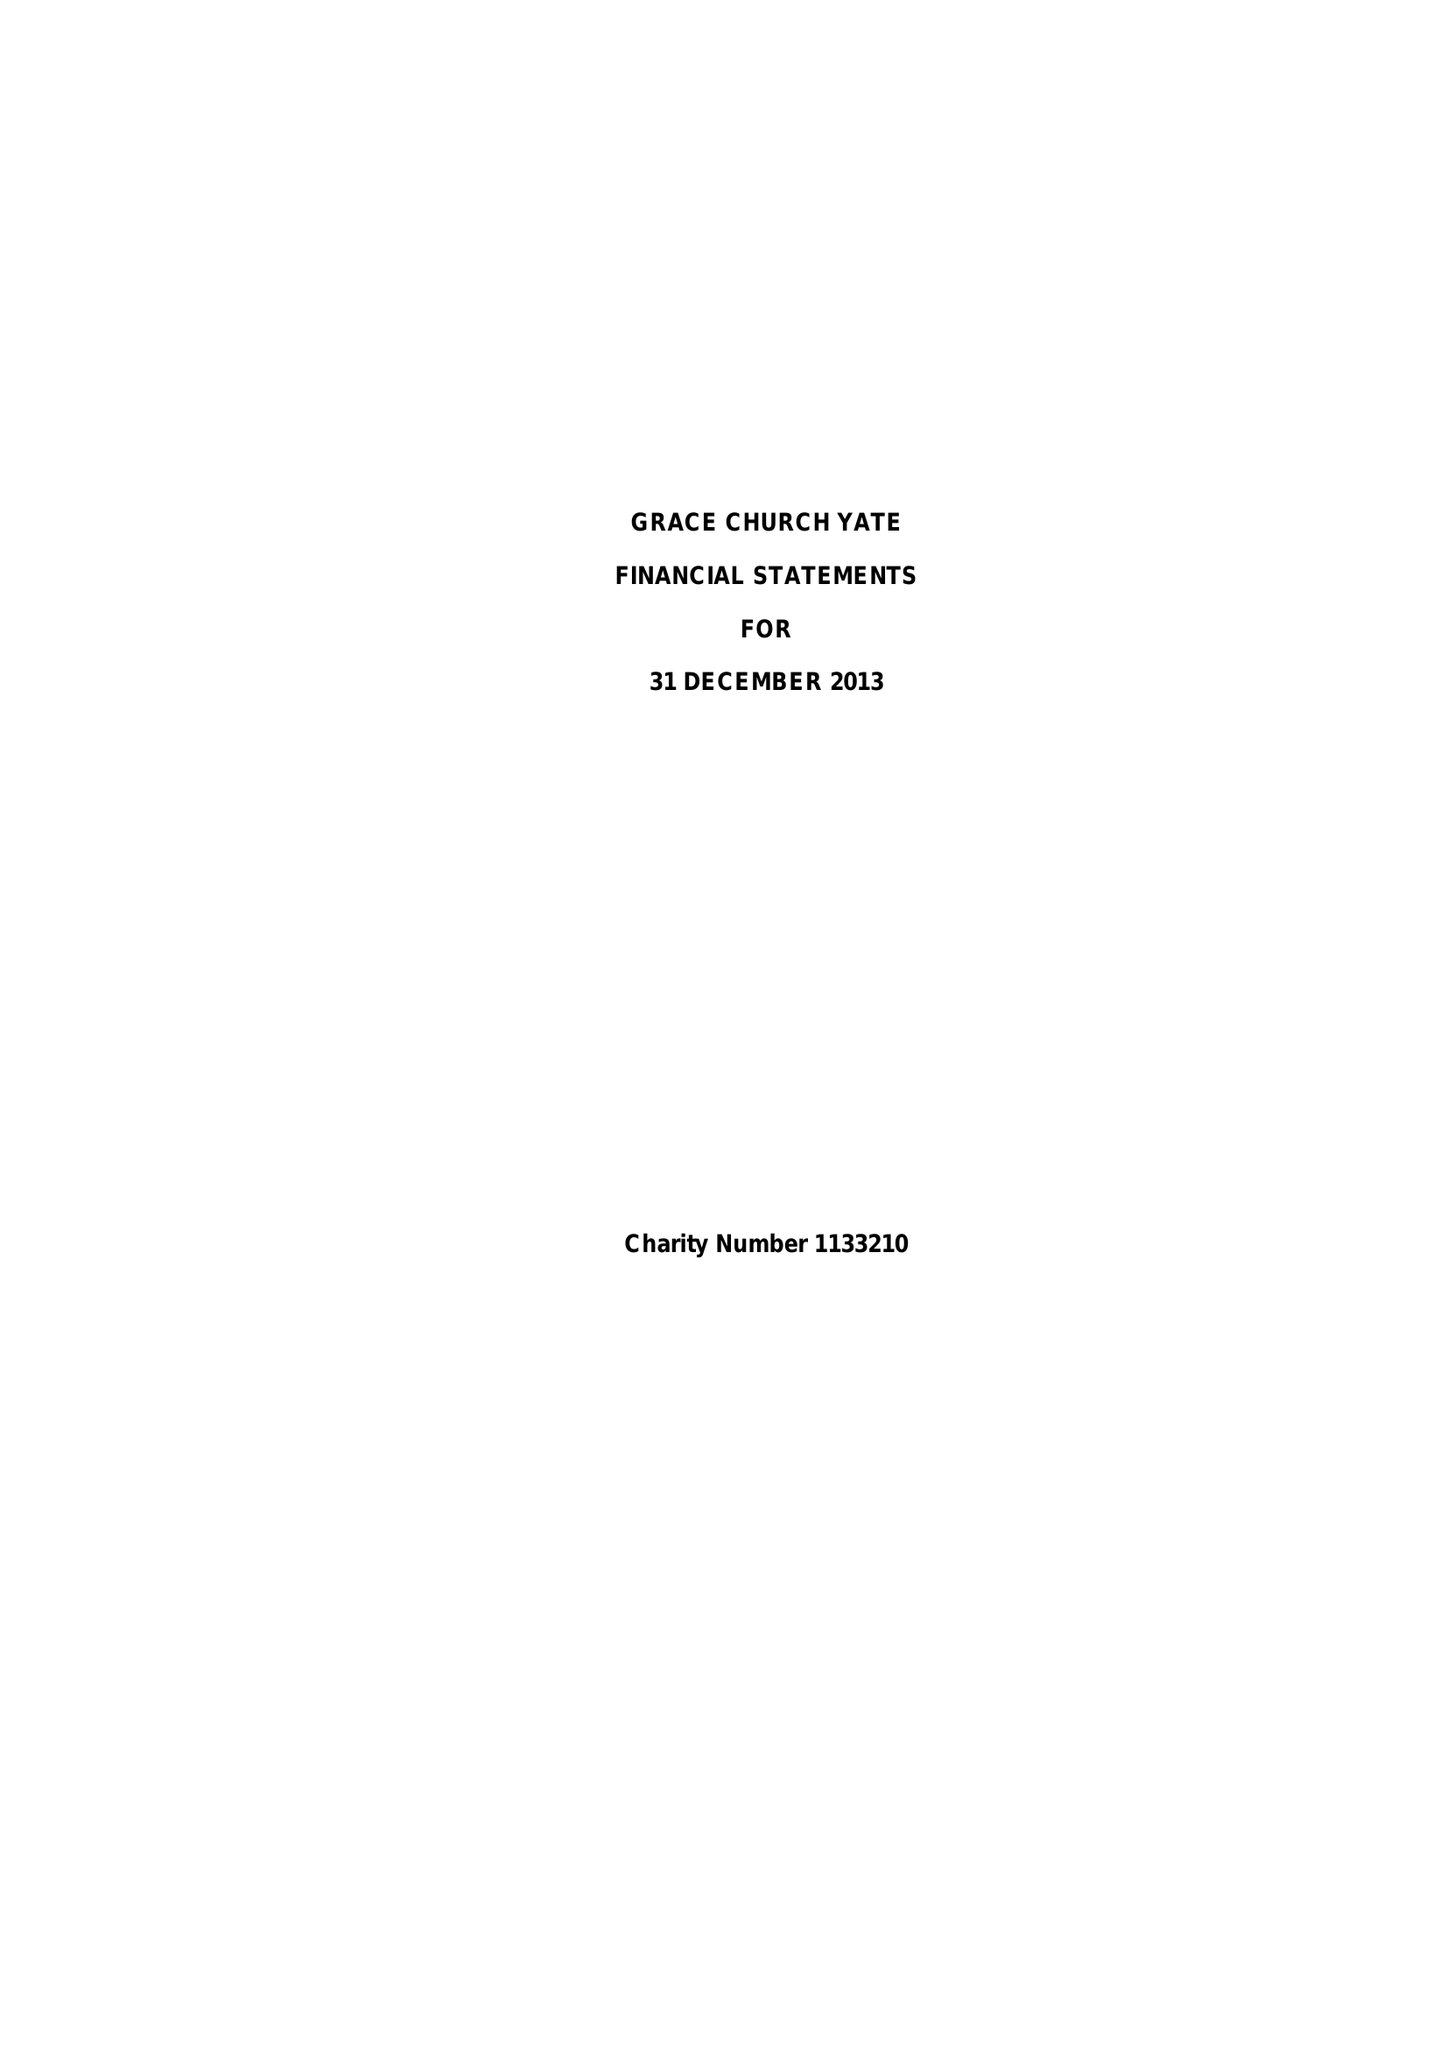What is the value for the report_date?
Answer the question using a single word or phrase. 2013-12-31 